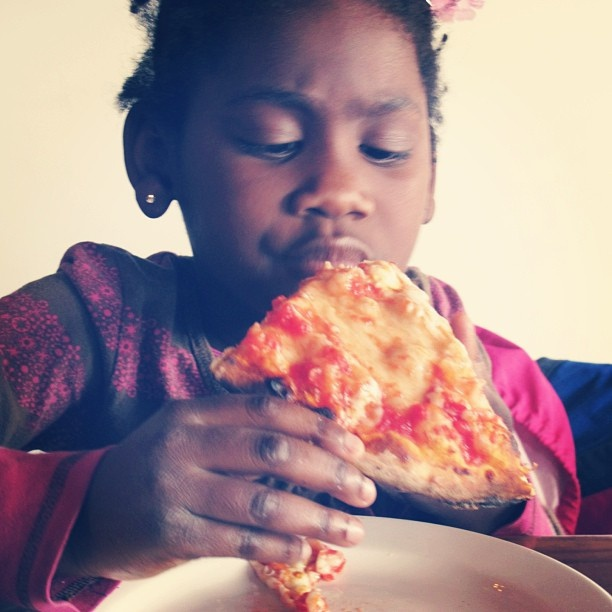Describe the objects in this image and their specific colors. I can see people in beige, navy, purple, lightpink, and gray tones and pizza in beige, tan, and salmon tones in this image. 